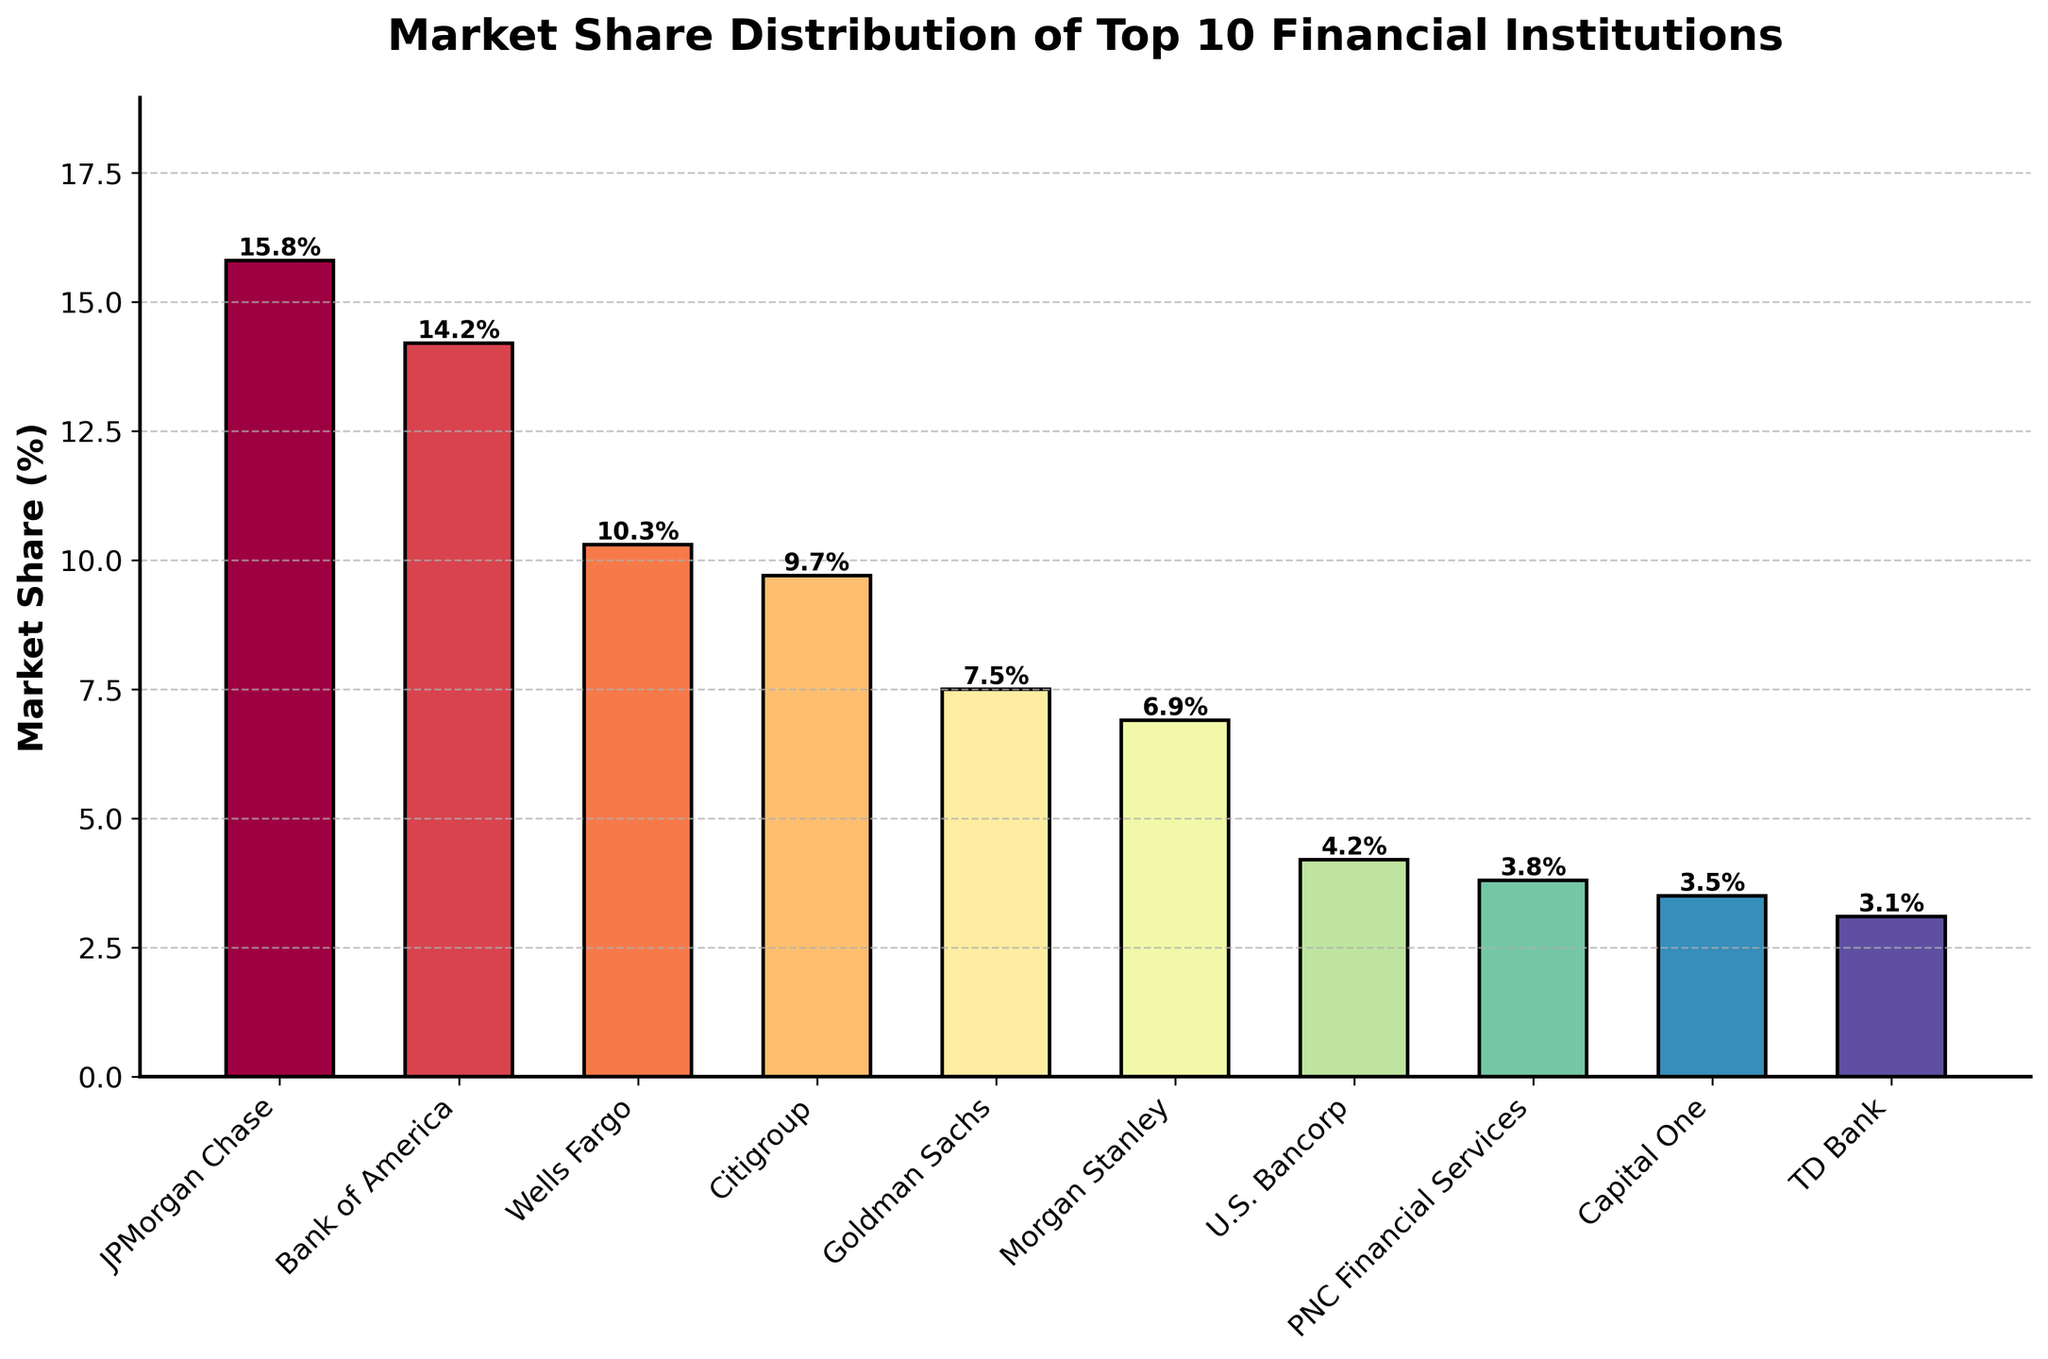What is the combined market share of JPMorgan Chase and Bank of America? We need to add the market shares of JPMorgan Chase (15.8%) and Bank of America (14.2%). So, 15.8 + 14.2 = 30.0
Answer: 30.0 Which financial institution has the smallest market share? By looking at the heights of the bars representing each institution, TD Bank has the shortest bar with a market share of 3.1%.
Answer: TD Bank How does Goldman Sachs' market share compare to Morgan Stanley's? The bar representing Goldman Sachs (7.5%) is taller than that of Morgan Stanley (6.9%). Hence, Goldman Sachs has a higher market share.
Answer: Goldman Sachs has a higher market share Which institutions have a market share less than 5%? By observing the height of the bars, U.S. Bancorp (4.2%), PNC Financial Services (3.8%), Capital One (3.5%), and TD Bank (3.1%) all have market shares less than 5%.
Answer: U.S. Bancorp, PNC Financial Services, Capital One, TD Bank What is the difference in market share between Wells Fargo and Citigroup? Subtract Citigroup's market share (9.7%) from Wells Fargo's market share (10.3%). So, 10.3 - 9.7 = 0.6
Answer: 0.6 Which institution holds the second-largest market share? By observing the heights of the bars, JPMorgan Chase is the largest, followed by Bank of America with a market share of 14.2%.
Answer: Bank of America How many institutions have a market share greater than or equal to 10%? By counting the bars with heights representing market shares of 10% or more, JPMorgan Chase (15.8%), Bank of America (14.2%), and Wells Fargo (10.3%) fit this criterion.
Answer: 3 What is the median market share of the top 10 financial institutions? Arrange their market shares in ascending order: 3.1, 3.5, 3.8, 4.2, 6.9, 7.5, 9.7, 10.3, 14.2, 15.8. The median is the average of the 5th and 6th values, (6.9 + 7.5)/2 = 7.2
Answer: 7.2 What is the total market share of the top 5 financial institutions? Add the market shares of the top 5 institutions: JPMorgan Chase (15.8%), Bank of America (14.2%), Wells Fargo (10.3%), Citigroup (9.7%), and Goldman Sachs (7.5%). So, 15.8 + 14.2 + 10.3 + 9.7 + 7.5 = 57.5
Answer: 57.5 Which institution's market share is closest to the average market share of the top 10 institutions? First, calculate the average market share: (15.8 + 14.2 + 10.3 + 9.7 + 7.5 + 6.9 + 4.2 + 3.8 + 3.5 + 3.1)/10 = 7.9. Then, compare the deviations of each institution's market share from this average. Morgan Stanley (6.9) has the smallest deviation (7.9 - 6.9 = 1.0).
Answer: Morgan Stanley 